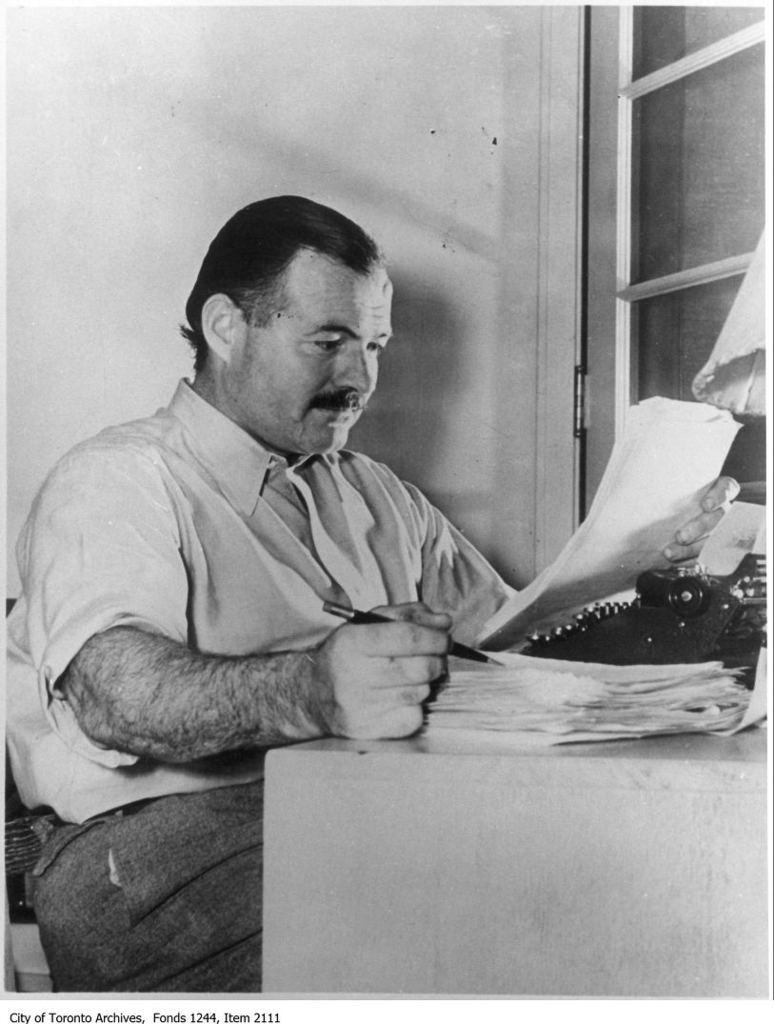How would you summarize this image in a sentence or two? There is a man sitting and holding paper and pen,in front of this ,man we can see papers and object on table. We can see wall and window. 